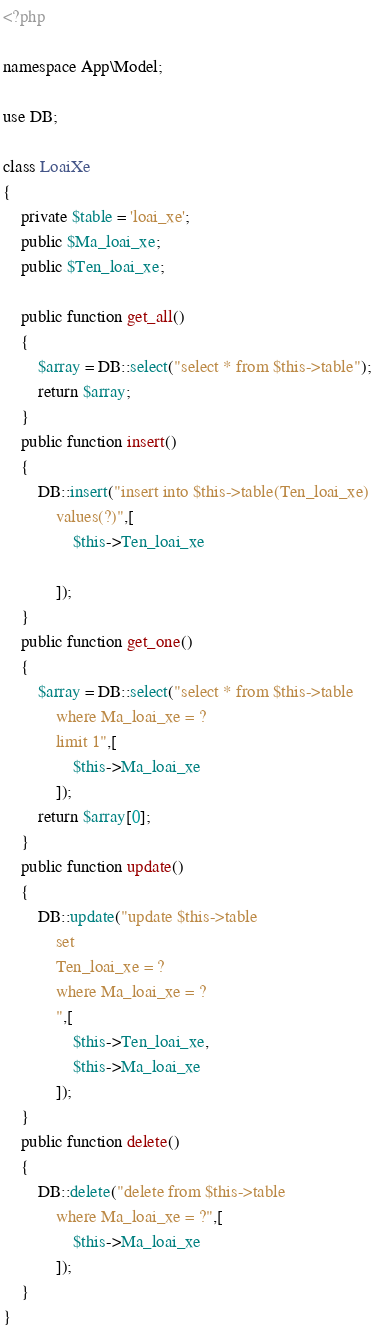Convert code to text. <code><loc_0><loc_0><loc_500><loc_500><_PHP_><?php 

namespace App\Model;

use DB;

class LoaiXe
{
	private $table = 'loai_xe';
	public $Ma_loai_xe;
	public $Ten_loai_xe;
	
	public function get_all()
	{
		$array = DB::select("select * from $this->table");
		return $array;
	}
	public function insert()
	{
		DB::insert("insert into $this->table(Ten_loai_xe)
			values(?)",[
				$this->Ten_loai_xe
				
			]);
	}
	public function get_one()
	{
		$array = DB::select("select * from $this->table
			where Ma_loai_xe = ?
			limit 1",[
				$this->Ma_loai_xe
			]);
		return $array[0];
	}
	public function update()
	{
		DB::update("update $this->table
			set
			Ten_loai_xe = ?
			where Ma_loai_xe = ?
			",[
				$this->Ten_loai_xe,
				$this->Ma_loai_xe
			]);
	}
	public function delete()
	{
		DB::delete("delete from $this->table
			where Ma_loai_xe = ?",[
				$this->Ma_loai_xe
			]);
	}
}</code> 